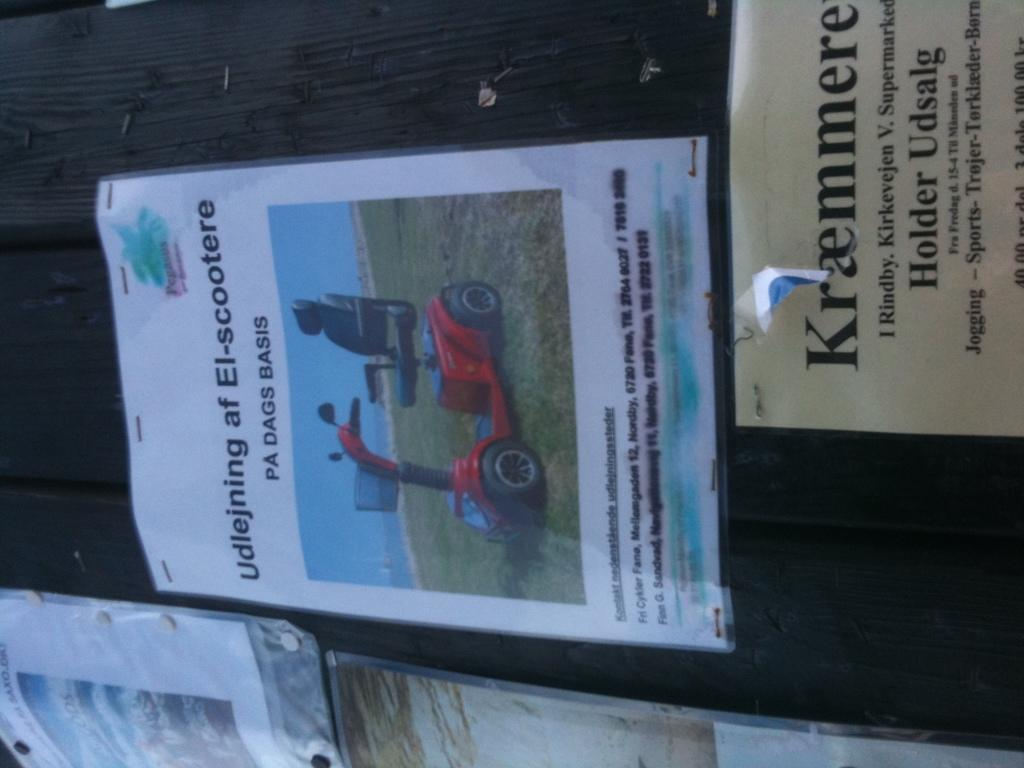What is the main object in the image? There is a notice board in the image. What is attached to the notice board? There are different posters pinned to the notice board. Where is the holiday table located in the image? There is no holiday table present in the image. What type of wrench is being used to hang the posters on the notice board? There is no wrench visible in the image, and the posters are already pinned to the notice board. 